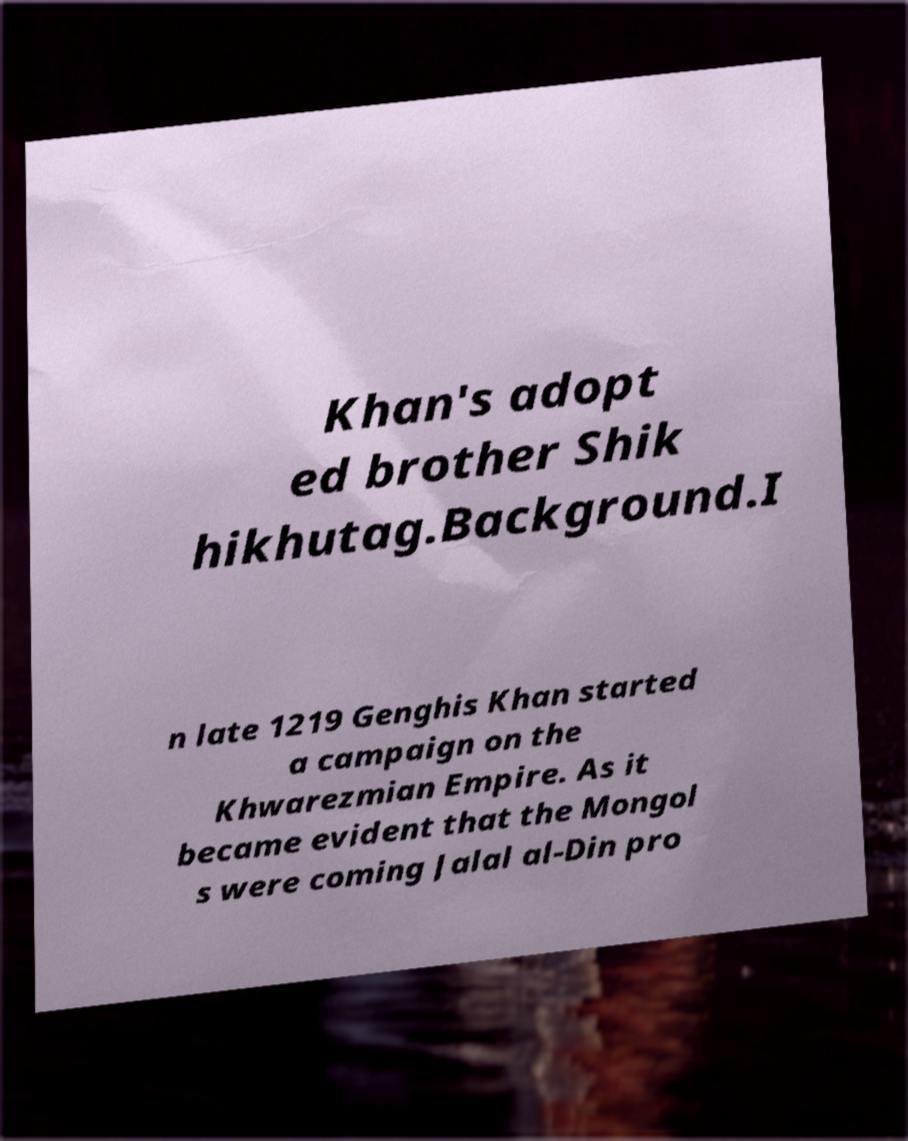There's text embedded in this image that I need extracted. Can you transcribe it verbatim? Khan's adopt ed brother Shik hikhutag.Background.I n late 1219 Genghis Khan started a campaign on the Khwarezmian Empire. As it became evident that the Mongol s were coming Jalal al-Din pro 